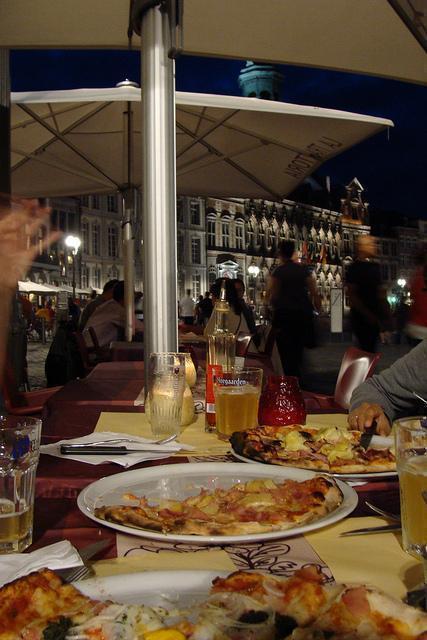What is this place?
Indicate the correct choice and explain in the format: 'Answer: answer
Rationale: rationale.'
Options: Waste disposal, picnic, outdoor restaurant, farmers market. Answer: outdoor restaurant.
Rationale: You can see the sky so they are outside. 